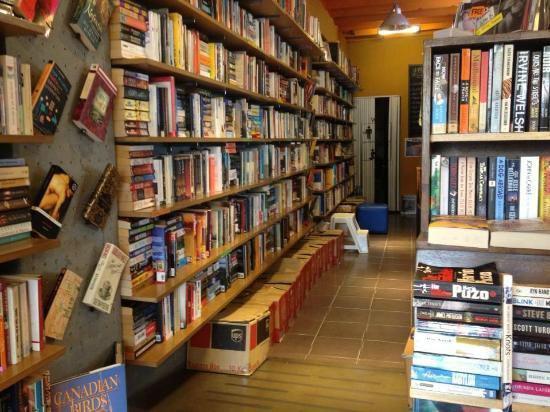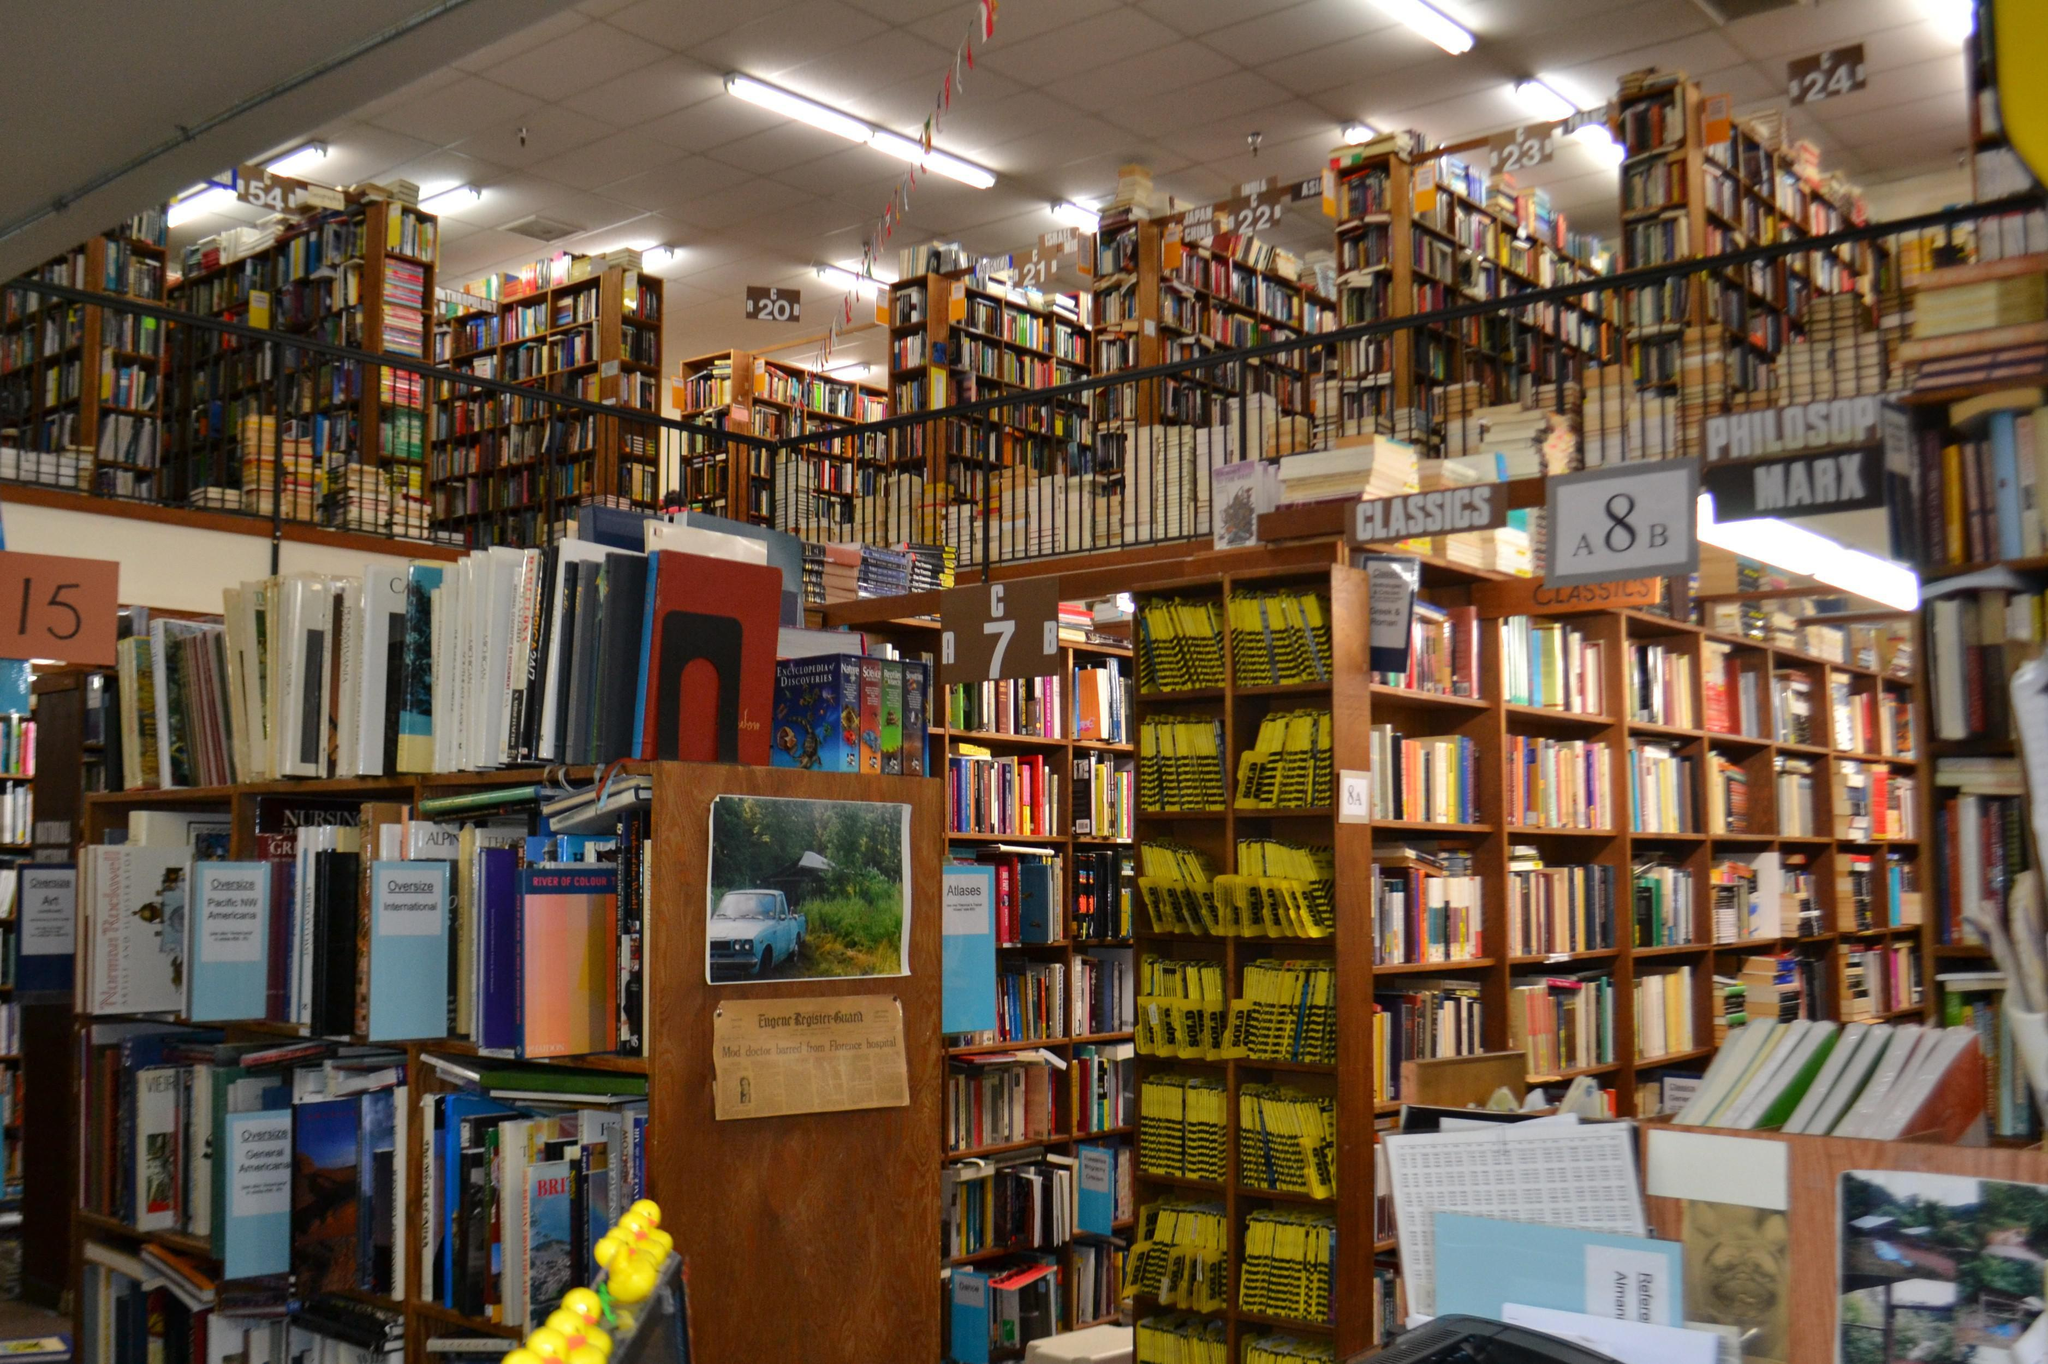The first image is the image on the left, the second image is the image on the right. Examine the images to the left and right. Is the description "One image is straight down an uncluttered, carpeted aisle with books shelved on both sides." accurate? Answer yes or no. No. 